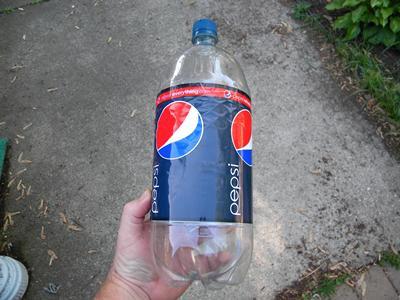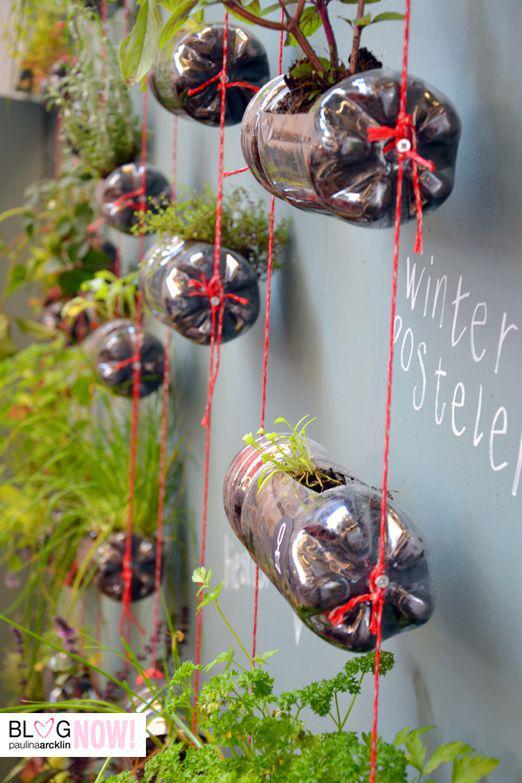The first image is the image on the left, the second image is the image on the right. Examine the images to the left and right. Is the description "One of the images contains two or fewer bottles." accurate? Answer yes or no. Yes. The first image is the image on the left, the second image is the image on the right. For the images displayed, is the sentence "Some bottles are cut open." factually correct? Answer yes or no. Yes. 